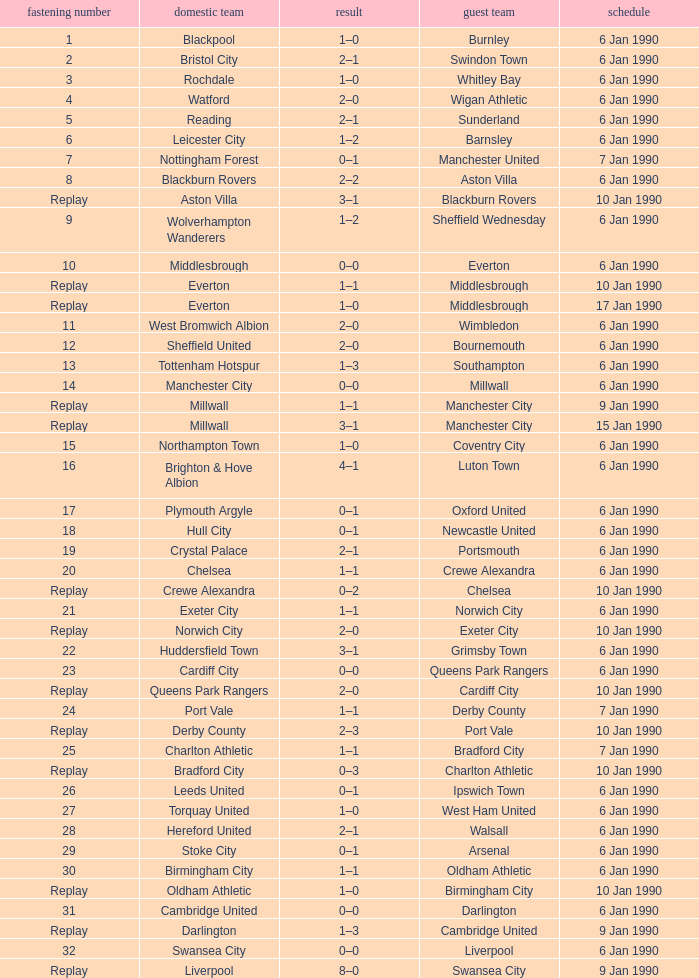What date did home team liverpool play? 9 Jan 1990. 